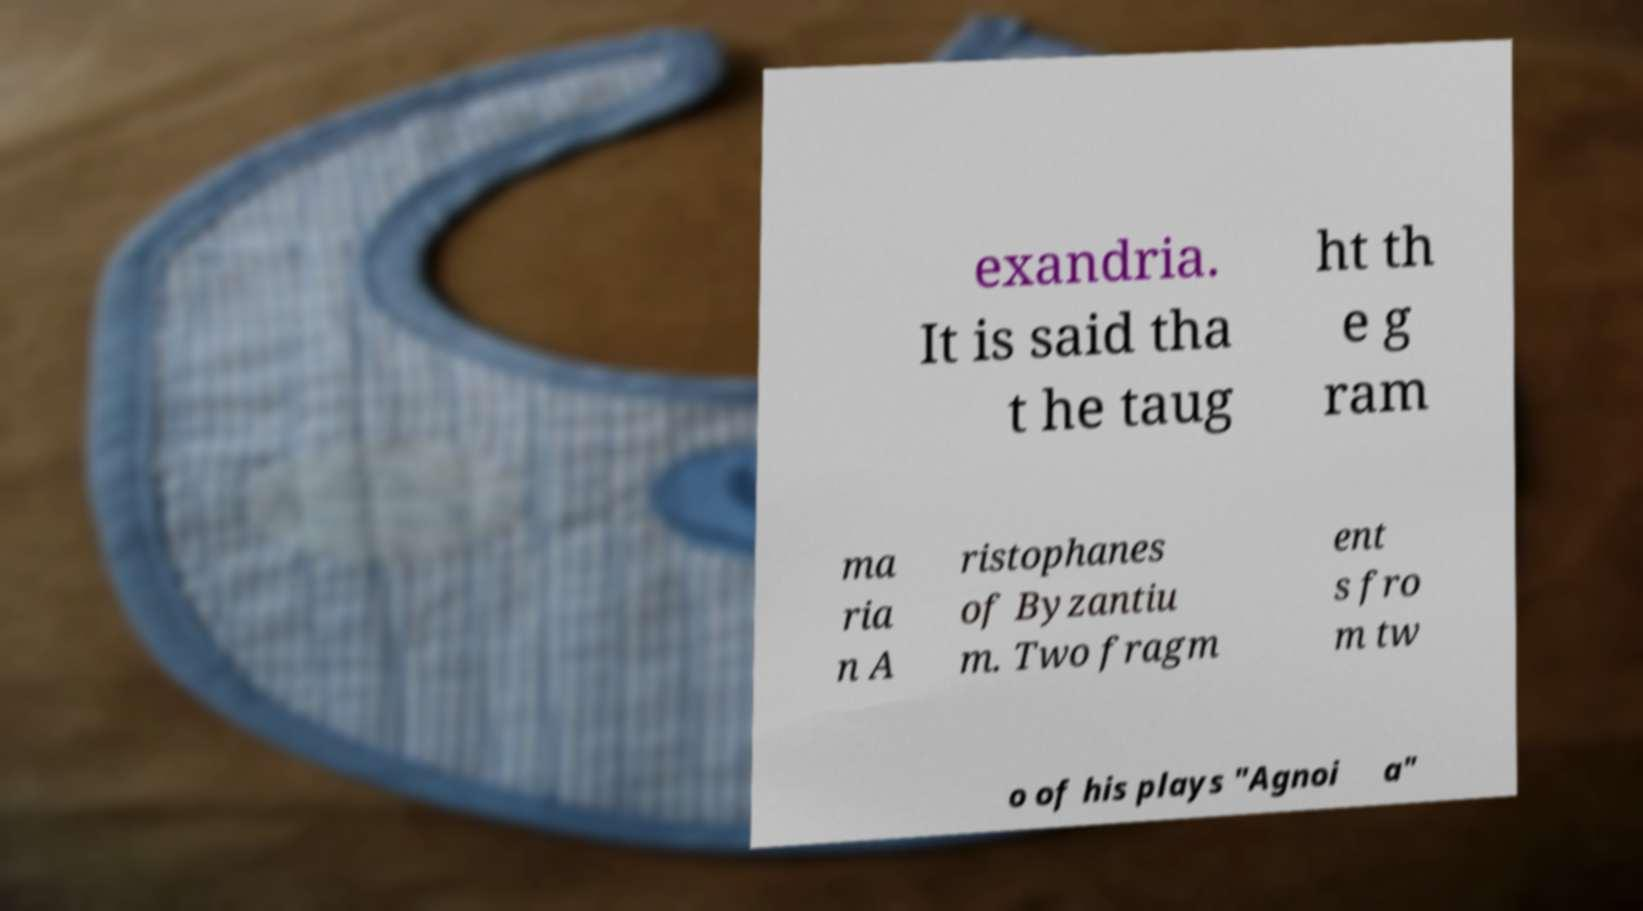What messages or text are displayed in this image? I need them in a readable, typed format. exandria. It is said tha t he taug ht th e g ram ma ria n A ristophanes of Byzantiu m. Two fragm ent s fro m tw o of his plays "Agnoi a" 